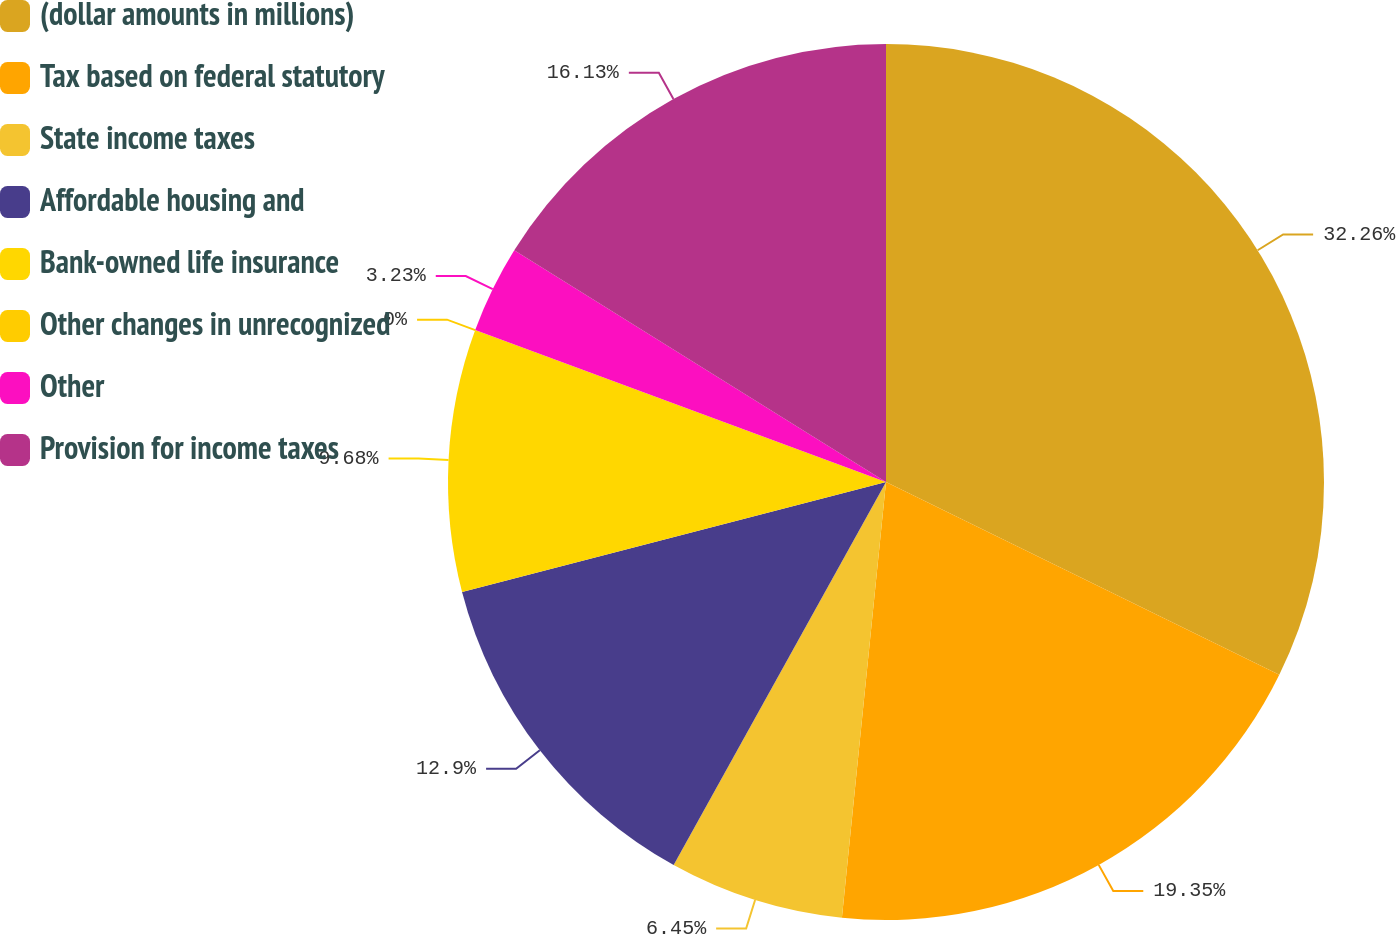Convert chart to OTSL. <chart><loc_0><loc_0><loc_500><loc_500><pie_chart><fcel>(dollar amounts in millions)<fcel>Tax based on federal statutory<fcel>State income taxes<fcel>Affordable housing and<fcel>Bank-owned life insurance<fcel>Other changes in unrecognized<fcel>Other<fcel>Provision for income taxes<nl><fcel>32.25%<fcel>19.35%<fcel>6.45%<fcel>12.9%<fcel>9.68%<fcel>0.0%<fcel>3.23%<fcel>16.13%<nl></chart> 